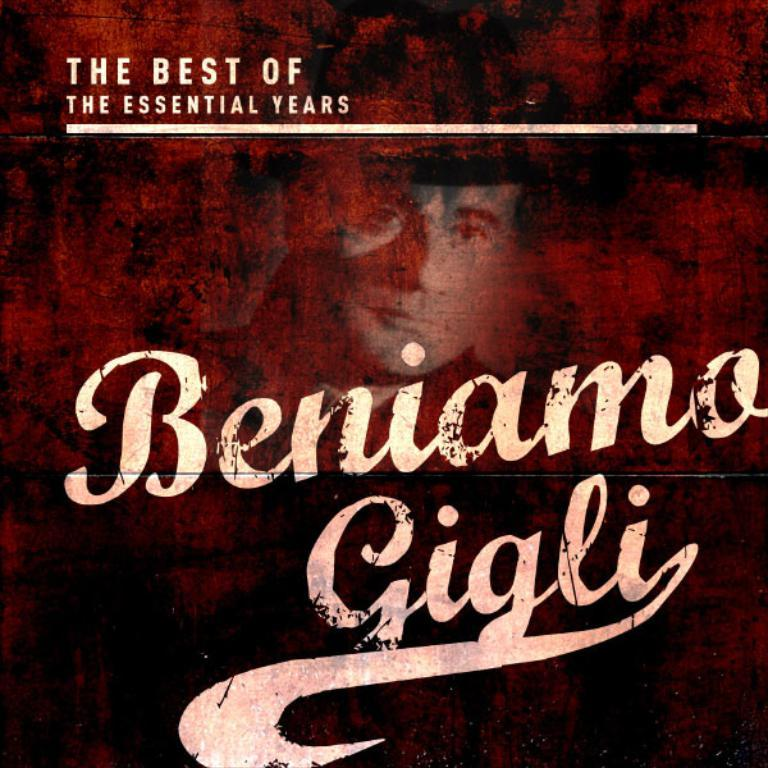<image>
Offer a succinct explanation of the picture presented. Beniamo Gigli, the best of the essential years, in a dark brown cover 